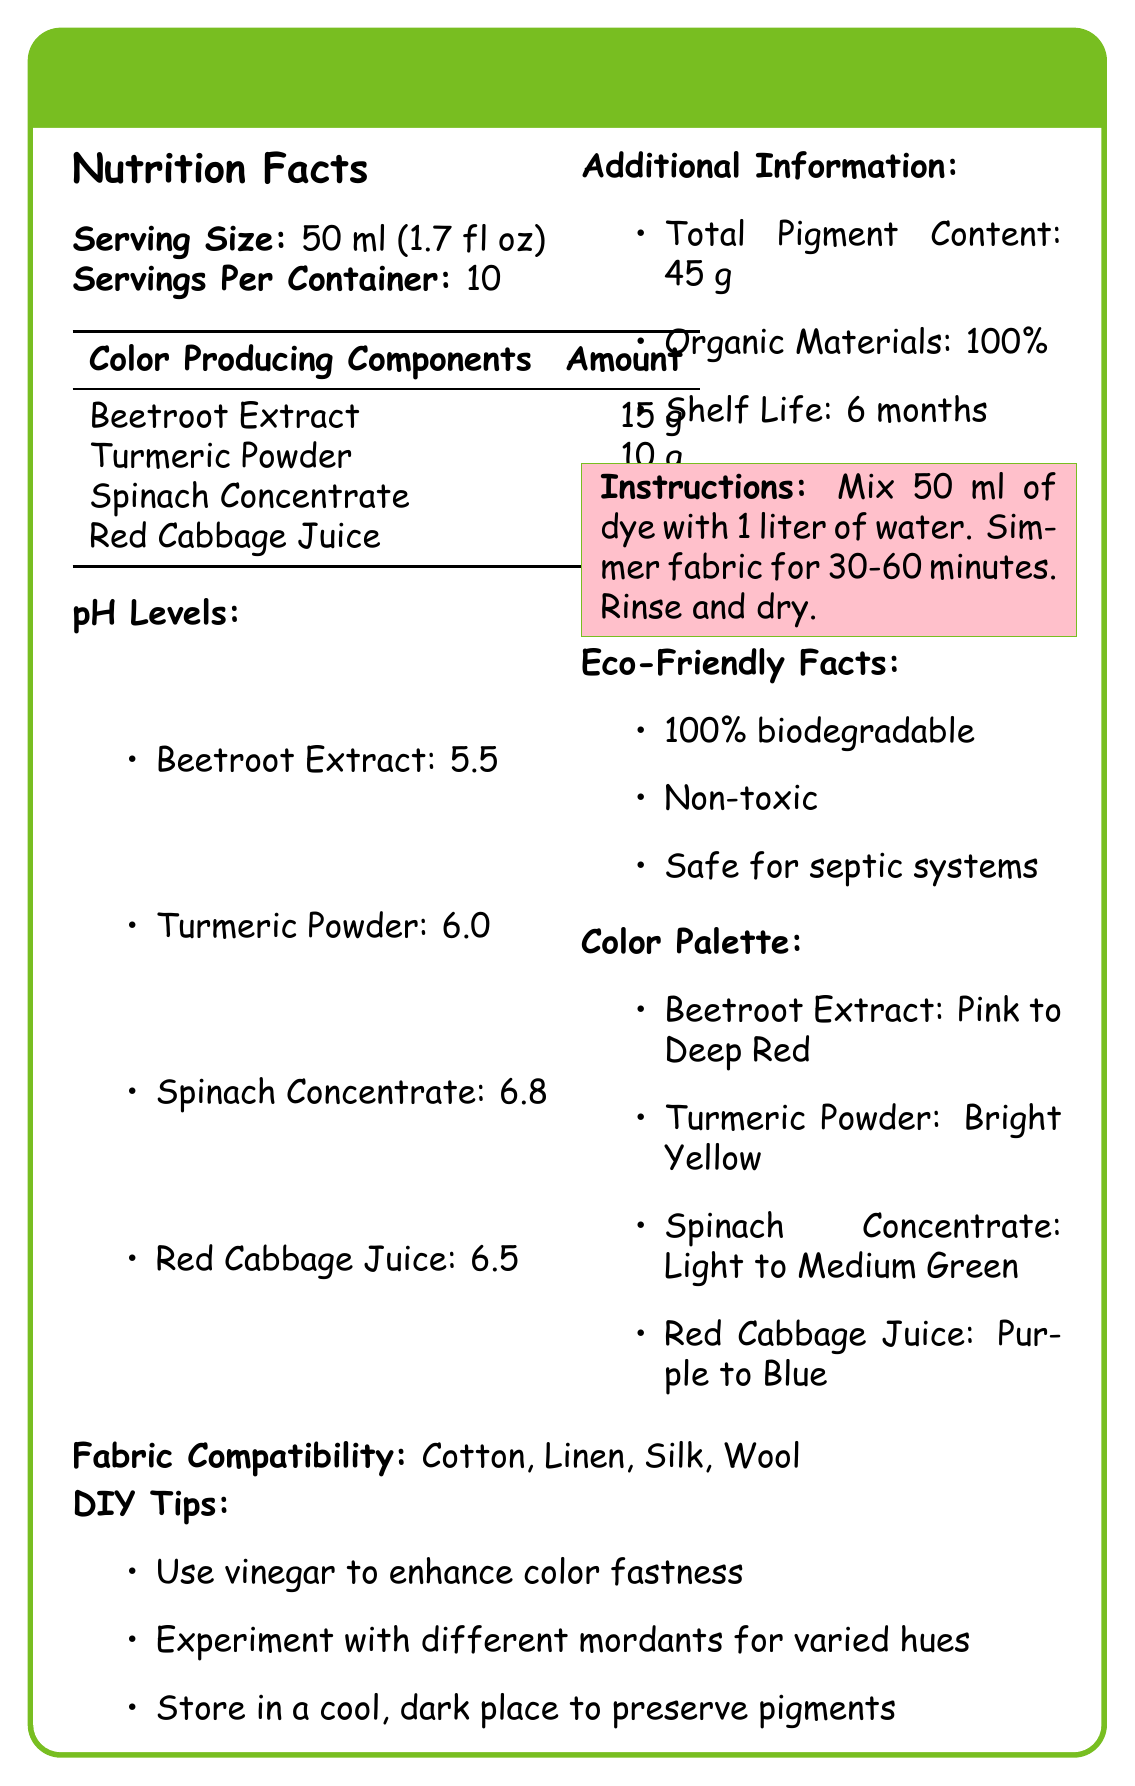what is the serving size? The label explicitly states the serving size as 50 ml (1.7 fl oz).
Answer: 50 ml (1.7 fl oz) how many servings are in one container? According to the document, there are 10 servings per container.
Answer: 10 which color-producing component has the highest pH level? The pH levels listed show Spinach Concentrate with the highest pH level of 6.8.
Answer: Spinach Concentrate list the color it produces, the pH level, and the amount of Beetroot Extract. Beetroot Extract produces a color from Pink to Deep Red, has a pH level of 5.5, and an amount of 15 g according to the details provided.
Answer: Pink to Deep Red, 5.5, 15 g what is the total pigment content? The additional information section states the total pigment content is 45 g.
Answer: 45 g what materials are compatible with the dye? The document lists Cotton, Linen, Silk, and Wool as compatible materials with the dye.
Answer: Cotton, Linen, Silk, Wool which component produces a Bright Yellow color? A. Beetroot Extract B. Turmeric Powder C. Red Cabbage Juice The document mentions that Turmeric Powder produces a Bright Yellow color.
Answer: B which component has a pH level of 6.5? A. Beetroot Extract B. Spinach Concentrate C. Red Cabbage Juice The label shows Red Cabbage Juice has a pH level of 6.5.
Answer: C is the dye 100% biodegradable? The eco-friendly facts section states that it is 100% biodegradable.
Answer: Yes summarize the document. This summary captures the main sections and details provided in the document.
Answer: The document provides detailed information about a Natural Vegetable Fabric Dye, covering serving size, serving per container, color-producing components along with their amounts and pH levels, additional information like total pigment content, organic materials, and shelf life. It also includes instructions for use, eco-friendly facts, color palette descriptions, fabric compatibility, and DIY tips. can I use this dye on synthetic fabrics? The document only mentions compatibility with Cotton, Linen, Silk, and Wool but does not provide information about synthetic fabrics.
Answer: Cannot be determined 